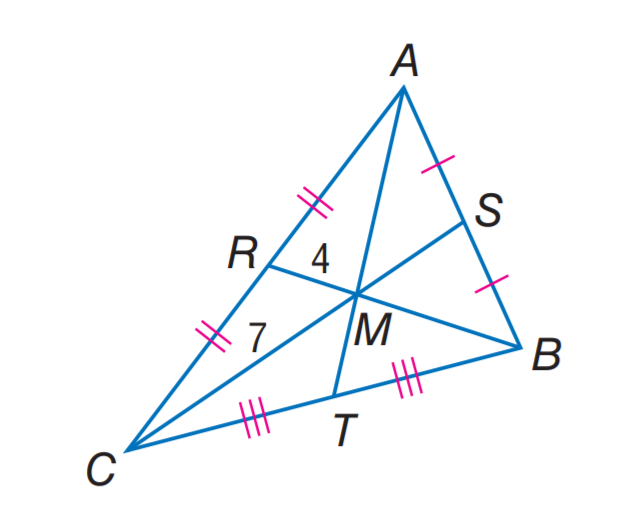Question: M C = 7, R M = 4, and A T = 16. Find R B.
Choices:
A. 6
B. 8
C. 12
D. 15
Answer with the letter. Answer: C Question: M C = 7, R M = 4, and A T = 16. Find S C.
Choices:
A. 10.5
B. 12
C. 13.5
D. 21
Answer with the letter. Answer: A 